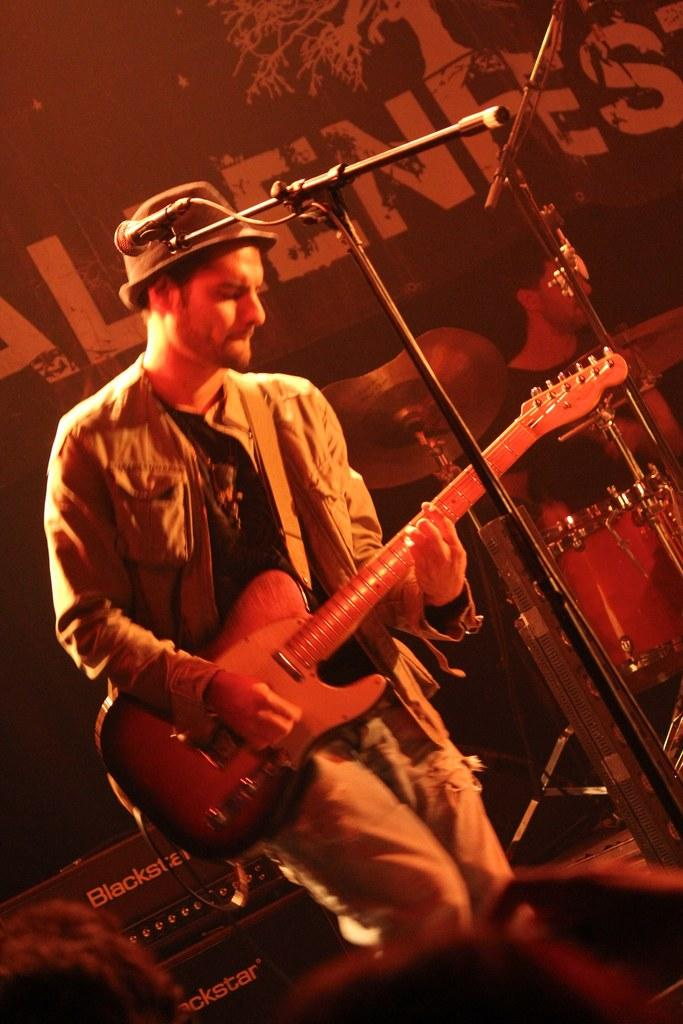What is the person in the image doing? The person in the image is playing a guitar. What object is in front of the person? There is a microphone in front of the person. What is the microphone attached to? The microphone is attached to a mic holder in the image. What type of object is the guitar? The guitar is a musical instrument. What type of animal can be seen balancing on the guitar in the image? There is no animal present in the image, and the guitar is not being balanced on by any object. 